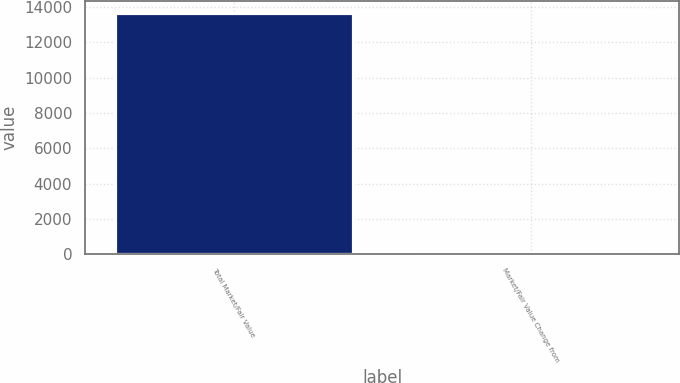Convert chart to OTSL. <chart><loc_0><loc_0><loc_500><loc_500><bar_chart><fcel>Total Market/Fair Value<fcel>Market/Fair Value Change from<nl><fcel>13645.7<fcel>2.8<nl></chart> 